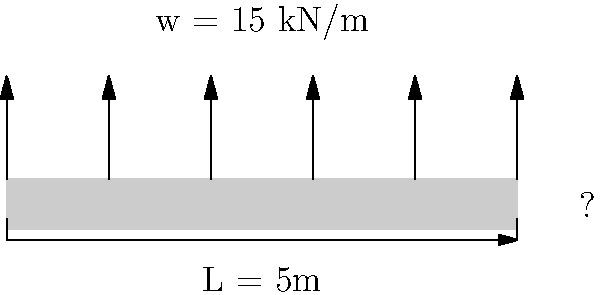As a business analyst with experience in retail, you're now working on a construction project. You need to determine the required thickness of a concrete slab for a store floor. The slab spans 5 meters and needs to support a uniformly distributed load of 15 kN/m. Given that the concrete has a compressive strength ($f'_c$) of 30 MPa and the allowable bending stress ($f_b$) is 5 MPa, calculate the minimum thickness of the slab. Assume a rectangular cross-section and use the simple beam formula: $M = \frac{wL^2}{8}$ and $f_b = \frac{6M}{bt^2}$, where $M$ is the maximum bending moment, $w$ is the uniformly distributed load, $L$ is the span, $b$ is the width (assume 1m), and $t$ is the thickness. Let's approach this step-by-step:

1) First, calculate the maximum bending moment (M):
   $M = \frac{wL^2}{8} = \frac{15 \text{ kN/m} \times (5 \text{ m})^2}{8} = 46.875 \text{ kNm}$

2) Now, use the bending stress formula and solve for t:
   $f_b = \frac{6M}{bt^2}$
   $5 \text{ MPa} = \frac{6 \times 46.875 \text{ kNm}}{1 \text{ m} \times t^2}$

3) Rearrange the equation:
   $t^2 = \frac{6 \times 46.875 \text{ kNm}}{5 \text{ MPa} \times 1 \text{ m}}$

4) Convert units (kNm to Nm):
   $t^2 = \frac{6 \times 46875 \text{ Nm}}{5 \times 10^6 \text{ Pa} \times 1 \text{ m}} = 0.05625 \text{ m}^2$

5) Take the square root:
   $t = \sqrt{0.05625} = 0.237 \text{ m}$

6) Round up to the nearest centimeter for practical purposes:
   $t = 0.24 \text{ m}$ or 24 cm
Answer: 24 cm 